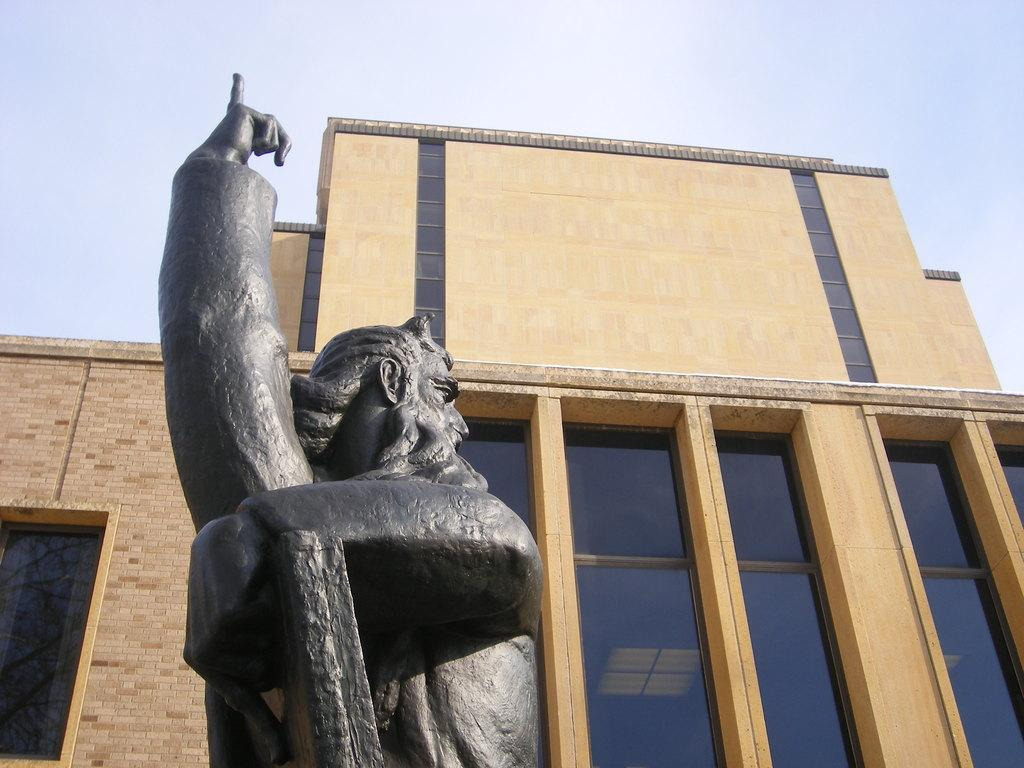What is the main subject in the foreground of the picture? There is a statue in the foreground of the picture. What type of building is visible in the center of the picture? There is a building with glass windows in the center of the picture. What material is used for the building's wall? The building has a brick wall. How would you describe the sky in the picture? The sky is cloudy. What is the taste of the joke being told in the picture? There is no joke present in the picture, so it cannot be tasted. 